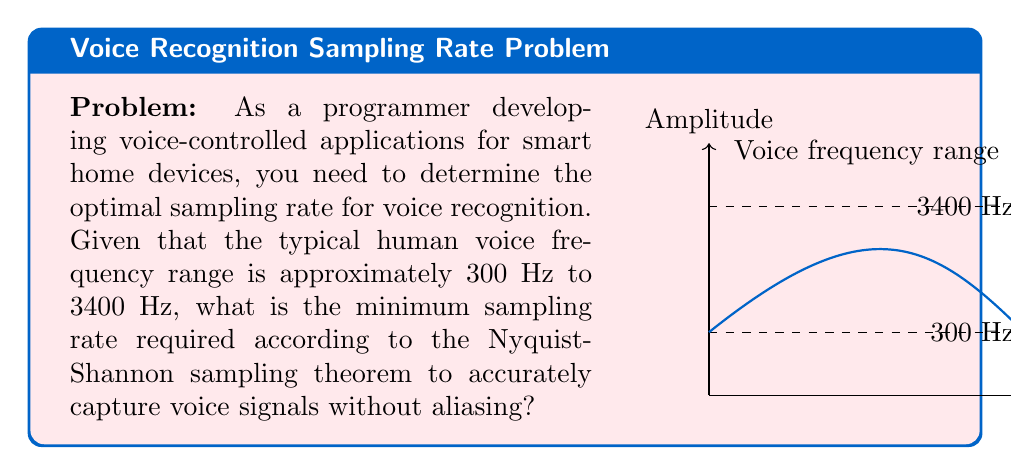Can you answer this question? To solve this problem, we'll follow these steps using the Nyquist-Shannon sampling theorem:

1) The Nyquist-Shannon sampling theorem states that to accurately reconstruct a signal, the sampling rate must be at least twice the highest frequency component of the signal.

2) In this case, the highest frequency component of the human voice is given as 3400 Hz.

3) Let's call the minimum required sampling rate $f_s$. According to the theorem:

   $$f_s \geq 2 \cdot f_{max}$$

   where $f_{max}$ is the maximum frequency in the signal.

4) Substituting the given value:

   $$f_s \geq 2 \cdot 3400 \text{ Hz}$$

5) Calculating:

   $$f_s \geq 6800 \text{ Hz}$$

6) Therefore, the minimum sampling rate required is 6800 Hz.

7) In practice, it's common to use a slightly higher sampling rate to account for non-ideal filters and other practical considerations. A common sampling rate used for voice applications is 8000 Hz, which provides some margin above the theoretical minimum.
Answer: 6800 Hz 